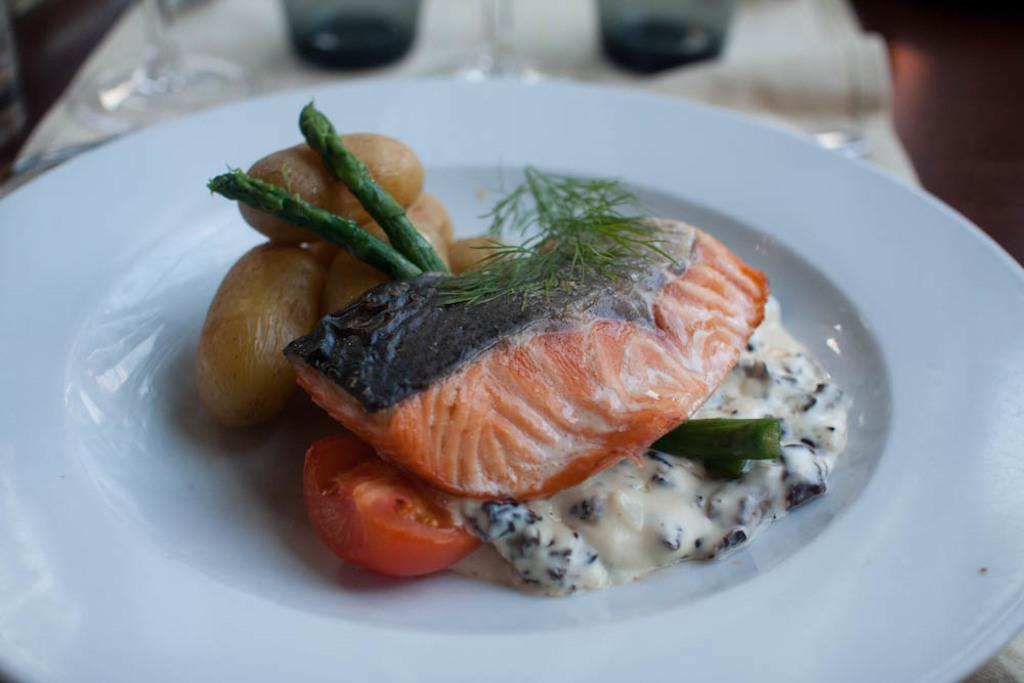What is on the plate that is visible in the image? There is food in a plate in the image. Can you describe anything else in the image besides the plate of food? Yes, there are objects visible in the background of the image. What type of fowl can be seen in the image? There is no fowl present in the image. What kind of lock is used to secure the camera in the image? There is no camera or lock present in the image. 